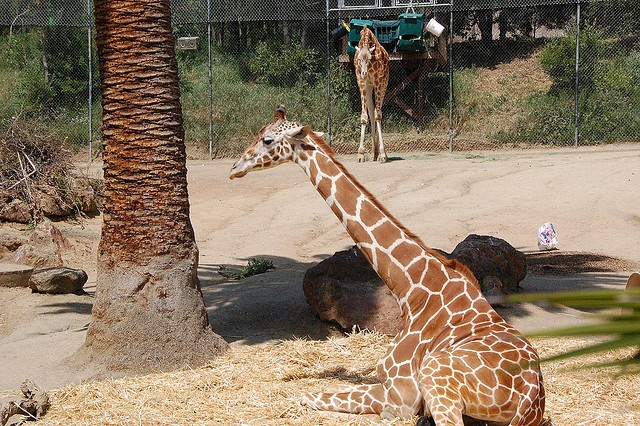Describe the objects in this image and their specific colors. I can see giraffe in gray, salmon, brown, white, and tan tones, giraffe in gray, maroon, tan, and black tones, and cup in gray, white, and darkgray tones in this image. 